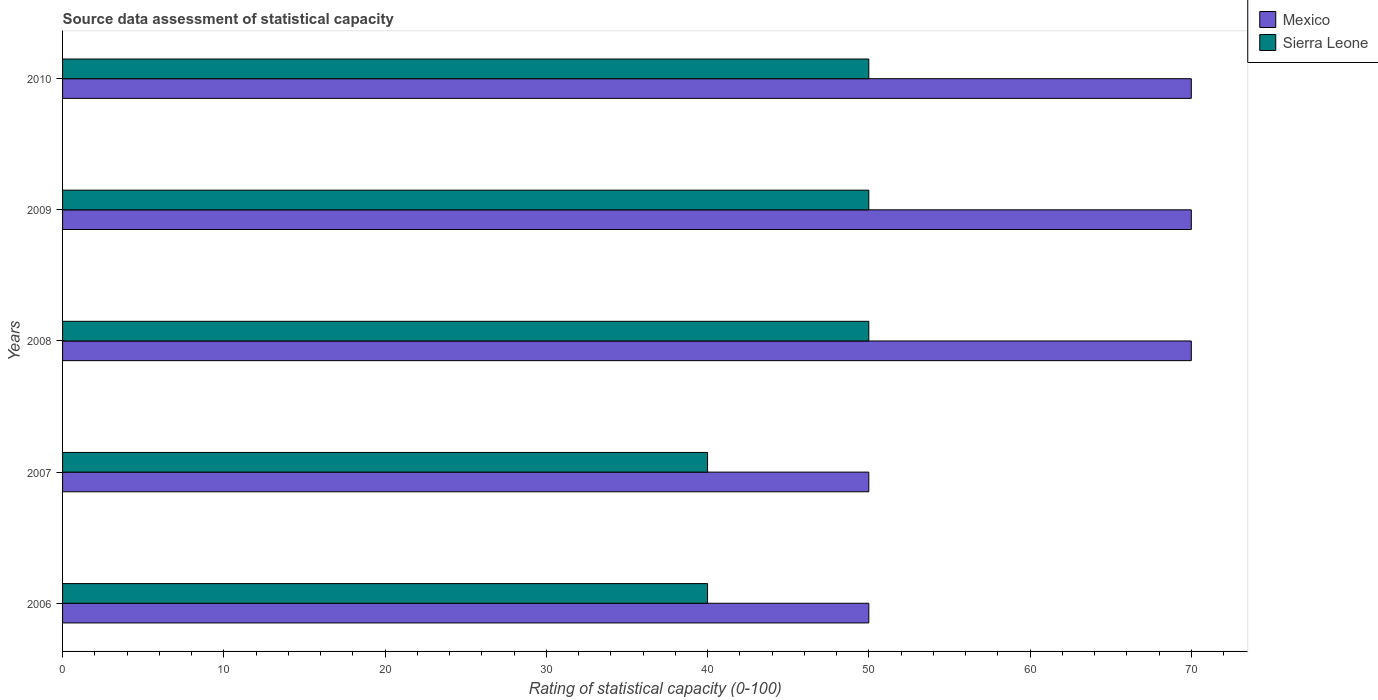How many groups of bars are there?
Keep it short and to the point. 5. Are the number of bars per tick equal to the number of legend labels?
Provide a succinct answer. Yes. How many bars are there on the 1st tick from the top?
Your response must be concise. 2. How many bars are there on the 5th tick from the bottom?
Your answer should be very brief. 2. What is the label of the 5th group of bars from the top?
Offer a terse response. 2006. What is the rating of statistical capacity in Mexico in 2007?
Offer a terse response. 50. Across all years, what is the maximum rating of statistical capacity in Sierra Leone?
Ensure brevity in your answer.  50. Across all years, what is the minimum rating of statistical capacity in Mexico?
Give a very brief answer. 50. In which year was the rating of statistical capacity in Mexico minimum?
Provide a succinct answer. 2006. What is the total rating of statistical capacity in Mexico in the graph?
Your answer should be compact. 310. What is the difference between the rating of statistical capacity in Sierra Leone in 2006 and the rating of statistical capacity in Mexico in 2007?
Your response must be concise. -10. In the year 2006, what is the difference between the rating of statistical capacity in Sierra Leone and rating of statistical capacity in Mexico?
Your answer should be compact. -10. In how many years, is the rating of statistical capacity in Sierra Leone greater than 8 ?
Your answer should be compact. 5. What is the ratio of the rating of statistical capacity in Mexico in 2007 to that in 2008?
Your response must be concise. 0.71. What is the difference between the highest and the second highest rating of statistical capacity in Mexico?
Offer a terse response. 0. What is the difference between the highest and the lowest rating of statistical capacity in Sierra Leone?
Ensure brevity in your answer.  10. What does the 2nd bar from the top in 2007 represents?
Your answer should be compact. Mexico. What does the 2nd bar from the bottom in 2006 represents?
Your response must be concise. Sierra Leone. Are all the bars in the graph horizontal?
Provide a succinct answer. Yes. Does the graph contain any zero values?
Ensure brevity in your answer.  No. Does the graph contain grids?
Give a very brief answer. No. Where does the legend appear in the graph?
Ensure brevity in your answer.  Top right. How many legend labels are there?
Keep it short and to the point. 2. What is the title of the graph?
Provide a succinct answer. Source data assessment of statistical capacity. Does "Senegal" appear as one of the legend labels in the graph?
Offer a terse response. No. What is the label or title of the X-axis?
Offer a terse response. Rating of statistical capacity (0-100). What is the label or title of the Y-axis?
Offer a very short reply. Years. What is the Rating of statistical capacity (0-100) in Mexico in 2007?
Your answer should be very brief. 50. What is the Rating of statistical capacity (0-100) of Sierra Leone in 2007?
Make the answer very short. 40. What is the Rating of statistical capacity (0-100) in Sierra Leone in 2008?
Offer a terse response. 50. What is the Rating of statistical capacity (0-100) in Sierra Leone in 2009?
Your response must be concise. 50. Across all years, what is the maximum Rating of statistical capacity (0-100) of Sierra Leone?
Your response must be concise. 50. Across all years, what is the minimum Rating of statistical capacity (0-100) of Mexico?
Your response must be concise. 50. What is the total Rating of statistical capacity (0-100) in Mexico in the graph?
Your answer should be compact. 310. What is the total Rating of statistical capacity (0-100) of Sierra Leone in the graph?
Keep it short and to the point. 230. What is the difference between the Rating of statistical capacity (0-100) of Mexico in 2006 and that in 2007?
Provide a succinct answer. 0. What is the difference between the Rating of statistical capacity (0-100) of Mexico in 2006 and that in 2008?
Make the answer very short. -20. What is the difference between the Rating of statistical capacity (0-100) of Sierra Leone in 2006 and that in 2009?
Give a very brief answer. -10. What is the difference between the Rating of statistical capacity (0-100) of Sierra Leone in 2006 and that in 2010?
Provide a short and direct response. -10. What is the difference between the Rating of statistical capacity (0-100) in Mexico in 2007 and that in 2008?
Your answer should be very brief. -20. What is the difference between the Rating of statistical capacity (0-100) of Sierra Leone in 2007 and that in 2008?
Give a very brief answer. -10. What is the difference between the Rating of statistical capacity (0-100) in Mexico in 2008 and that in 2009?
Offer a very short reply. 0. What is the difference between the Rating of statistical capacity (0-100) in Mexico in 2008 and that in 2010?
Offer a very short reply. 0. What is the difference between the Rating of statistical capacity (0-100) in Sierra Leone in 2009 and that in 2010?
Make the answer very short. 0. What is the difference between the Rating of statistical capacity (0-100) of Mexico in 2006 and the Rating of statistical capacity (0-100) of Sierra Leone in 2007?
Provide a short and direct response. 10. What is the difference between the Rating of statistical capacity (0-100) of Mexico in 2006 and the Rating of statistical capacity (0-100) of Sierra Leone in 2008?
Keep it short and to the point. 0. What is the difference between the Rating of statistical capacity (0-100) in Mexico in 2006 and the Rating of statistical capacity (0-100) in Sierra Leone in 2009?
Make the answer very short. 0. What is the difference between the Rating of statistical capacity (0-100) of Mexico in 2006 and the Rating of statistical capacity (0-100) of Sierra Leone in 2010?
Your response must be concise. 0. What is the difference between the Rating of statistical capacity (0-100) in Mexico in 2007 and the Rating of statistical capacity (0-100) in Sierra Leone in 2010?
Your response must be concise. 0. What is the difference between the Rating of statistical capacity (0-100) in Mexico in 2008 and the Rating of statistical capacity (0-100) in Sierra Leone in 2009?
Give a very brief answer. 20. What is the difference between the Rating of statistical capacity (0-100) of Mexico in 2009 and the Rating of statistical capacity (0-100) of Sierra Leone in 2010?
Your answer should be very brief. 20. What is the average Rating of statistical capacity (0-100) of Mexico per year?
Offer a very short reply. 62. In the year 2006, what is the difference between the Rating of statistical capacity (0-100) of Mexico and Rating of statistical capacity (0-100) of Sierra Leone?
Offer a very short reply. 10. In the year 2008, what is the difference between the Rating of statistical capacity (0-100) of Mexico and Rating of statistical capacity (0-100) of Sierra Leone?
Keep it short and to the point. 20. What is the ratio of the Rating of statistical capacity (0-100) of Mexico in 2006 to that in 2007?
Provide a short and direct response. 1. What is the ratio of the Rating of statistical capacity (0-100) in Mexico in 2006 to that in 2008?
Your answer should be compact. 0.71. What is the ratio of the Rating of statistical capacity (0-100) in Sierra Leone in 2006 to that in 2008?
Provide a succinct answer. 0.8. What is the ratio of the Rating of statistical capacity (0-100) in Mexico in 2007 to that in 2010?
Ensure brevity in your answer.  0.71. What is the ratio of the Rating of statistical capacity (0-100) in Sierra Leone in 2008 to that in 2009?
Provide a succinct answer. 1. What is the ratio of the Rating of statistical capacity (0-100) of Mexico in 2008 to that in 2010?
Provide a succinct answer. 1. What is the ratio of the Rating of statistical capacity (0-100) in Sierra Leone in 2009 to that in 2010?
Provide a short and direct response. 1. What is the difference between the highest and the second highest Rating of statistical capacity (0-100) of Mexico?
Your answer should be compact. 0. What is the difference between the highest and the lowest Rating of statistical capacity (0-100) of Mexico?
Keep it short and to the point. 20. What is the difference between the highest and the lowest Rating of statistical capacity (0-100) of Sierra Leone?
Keep it short and to the point. 10. 